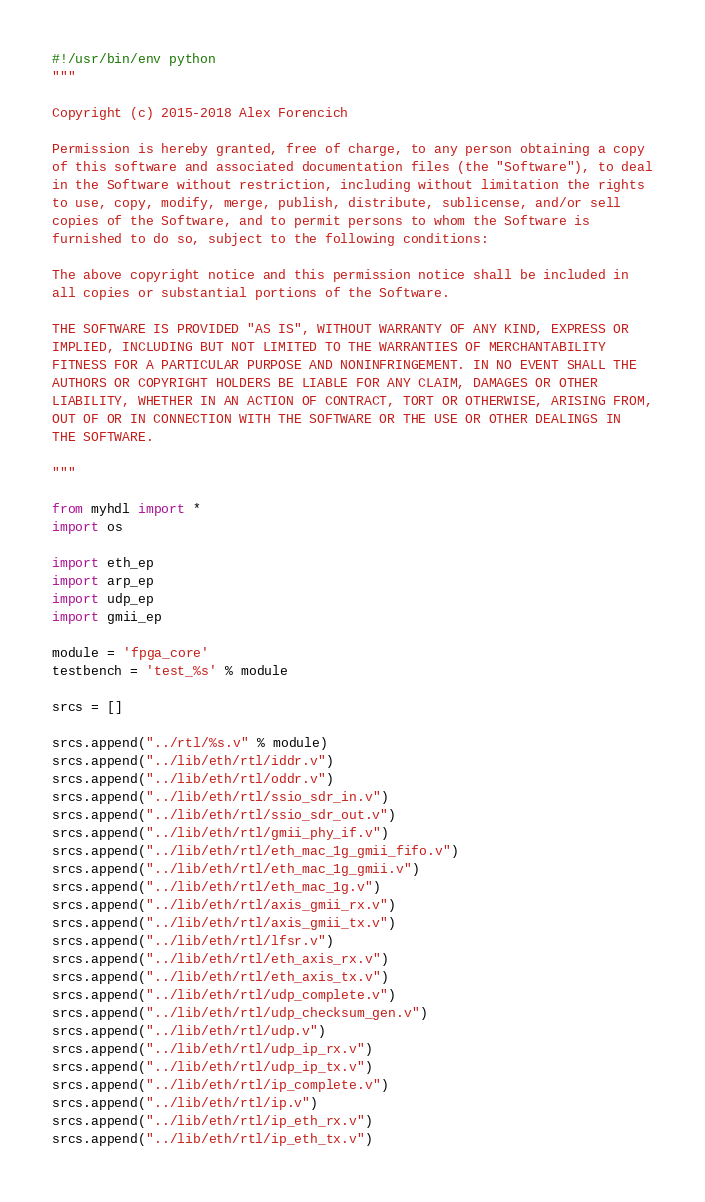<code> <loc_0><loc_0><loc_500><loc_500><_Python_>#!/usr/bin/env python
"""

Copyright (c) 2015-2018 Alex Forencich

Permission is hereby granted, free of charge, to any person obtaining a copy
of this software and associated documentation files (the "Software"), to deal
in the Software without restriction, including without limitation the rights
to use, copy, modify, merge, publish, distribute, sublicense, and/or sell
copies of the Software, and to permit persons to whom the Software is
furnished to do so, subject to the following conditions:

The above copyright notice and this permission notice shall be included in
all copies or substantial portions of the Software.

THE SOFTWARE IS PROVIDED "AS IS", WITHOUT WARRANTY OF ANY KIND, EXPRESS OR
IMPLIED, INCLUDING BUT NOT LIMITED TO THE WARRANTIES OF MERCHANTABILITY
FITNESS FOR A PARTICULAR PURPOSE AND NONINFRINGEMENT. IN NO EVENT SHALL THE
AUTHORS OR COPYRIGHT HOLDERS BE LIABLE FOR ANY CLAIM, DAMAGES OR OTHER
LIABILITY, WHETHER IN AN ACTION OF CONTRACT, TORT OR OTHERWISE, ARISING FROM,
OUT OF OR IN CONNECTION WITH THE SOFTWARE OR THE USE OR OTHER DEALINGS IN
THE SOFTWARE.

"""

from myhdl import *
import os

import eth_ep
import arp_ep
import udp_ep
import gmii_ep

module = 'fpga_core'
testbench = 'test_%s' % module

srcs = []

srcs.append("../rtl/%s.v" % module)
srcs.append("../lib/eth/rtl/iddr.v")
srcs.append("../lib/eth/rtl/oddr.v")
srcs.append("../lib/eth/rtl/ssio_sdr_in.v")
srcs.append("../lib/eth/rtl/ssio_sdr_out.v")
srcs.append("../lib/eth/rtl/gmii_phy_if.v")
srcs.append("../lib/eth/rtl/eth_mac_1g_gmii_fifo.v")
srcs.append("../lib/eth/rtl/eth_mac_1g_gmii.v")
srcs.append("../lib/eth/rtl/eth_mac_1g.v")
srcs.append("../lib/eth/rtl/axis_gmii_rx.v")
srcs.append("../lib/eth/rtl/axis_gmii_tx.v")
srcs.append("../lib/eth/rtl/lfsr.v")
srcs.append("../lib/eth/rtl/eth_axis_rx.v")
srcs.append("../lib/eth/rtl/eth_axis_tx.v")
srcs.append("../lib/eth/rtl/udp_complete.v")
srcs.append("../lib/eth/rtl/udp_checksum_gen.v")
srcs.append("../lib/eth/rtl/udp.v")
srcs.append("../lib/eth/rtl/udp_ip_rx.v")
srcs.append("../lib/eth/rtl/udp_ip_tx.v")
srcs.append("../lib/eth/rtl/ip_complete.v")
srcs.append("../lib/eth/rtl/ip.v")
srcs.append("../lib/eth/rtl/ip_eth_rx.v")
srcs.append("../lib/eth/rtl/ip_eth_tx.v")</code> 